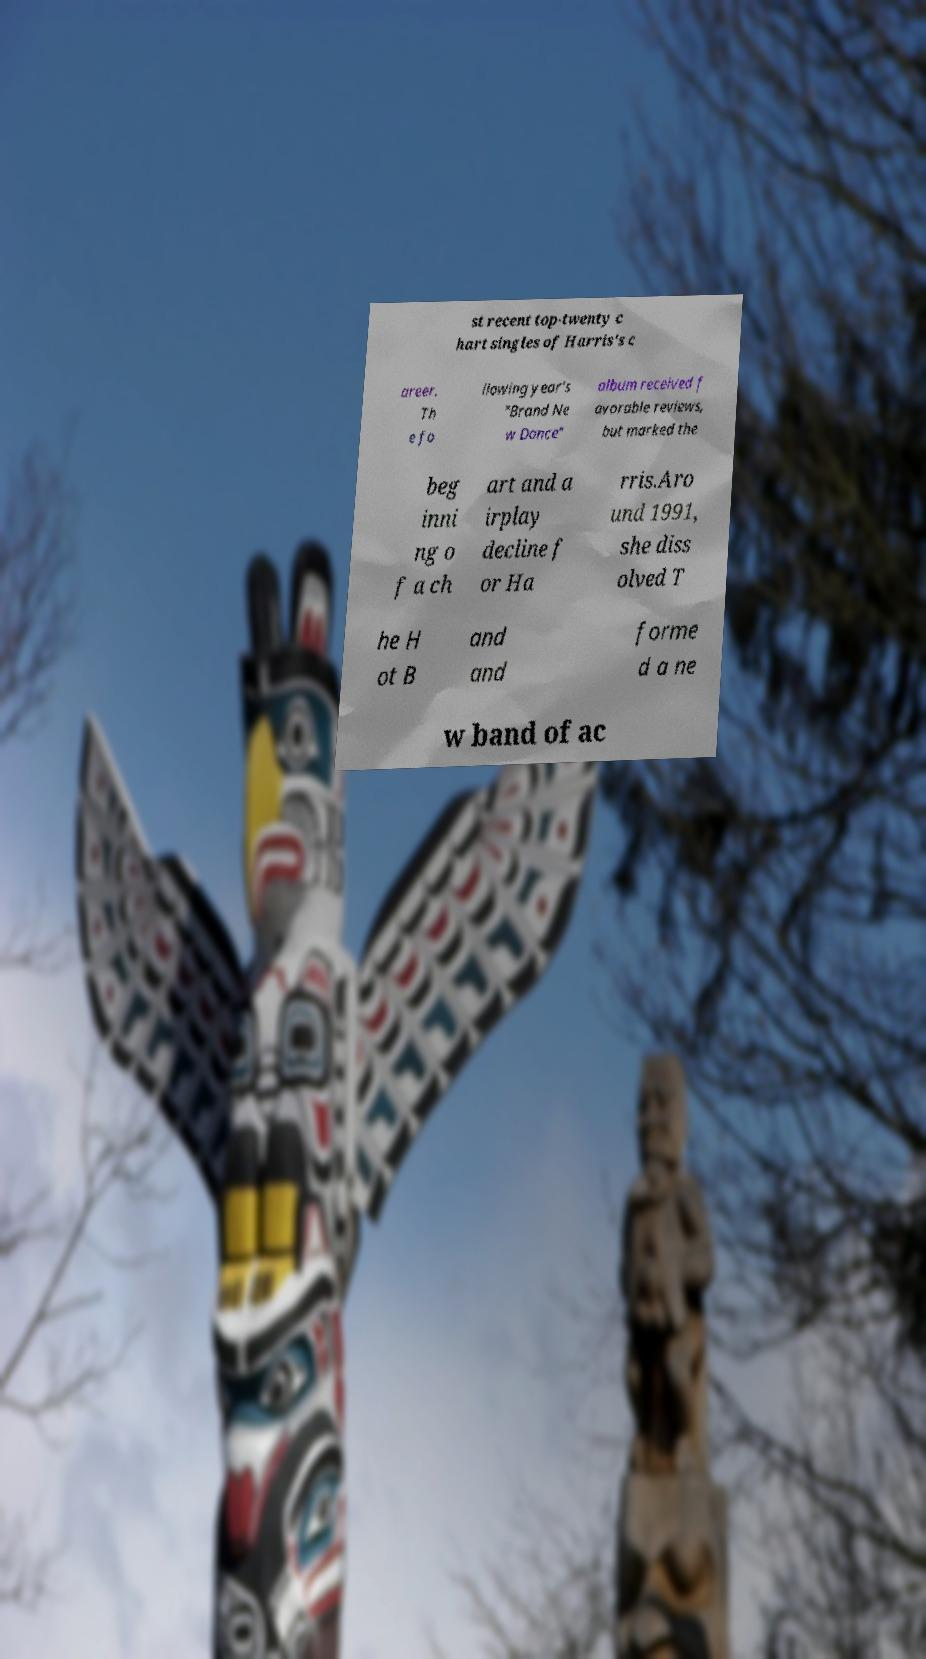There's text embedded in this image that I need extracted. Can you transcribe it verbatim? st recent top-twenty c hart singles of Harris's c areer. Th e fo llowing year's "Brand Ne w Dance" album received f avorable reviews, but marked the beg inni ng o f a ch art and a irplay decline f or Ha rris.Aro und 1991, she diss olved T he H ot B and and forme d a ne w band of ac 